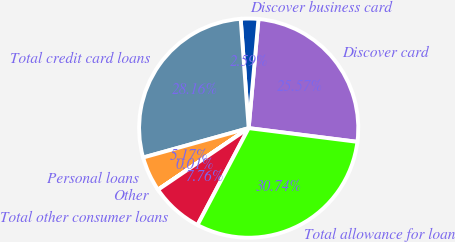<chart> <loc_0><loc_0><loc_500><loc_500><pie_chart><fcel>Discover card<fcel>Discover business card<fcel>Total credit card loans<fcel>Personal loans<fcel>Other<fcel>Total other consumer loans<fcel>Total allowance for loan<nl><fcel>25.57%<fcel>2.59%<fcel>28.16%<fcel>5.17%<fcel>0.01%<fcel>7.76%<fcel>30.74%<nl></chart> 